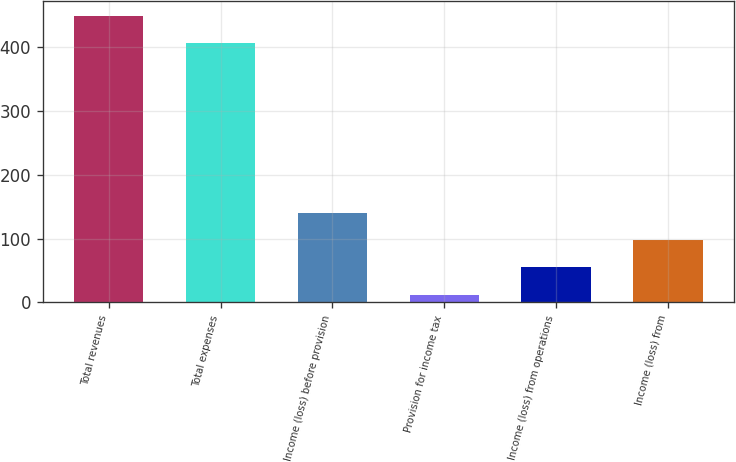<chart> <loc_0><loc_0><loc_500><loc_500><bar_chart><fcel>Total revenues<fcel>Total expenses<fcel>Income (loss) before provision<fcel>Provision for income tax<fcel>Income (loss) from operations<fcel>Income (loss) from<nl><fcel>448.8<fcel>406<fcel>140.4<fcel>12<fcel>54.8<fcel>97.6<nl></chart> 